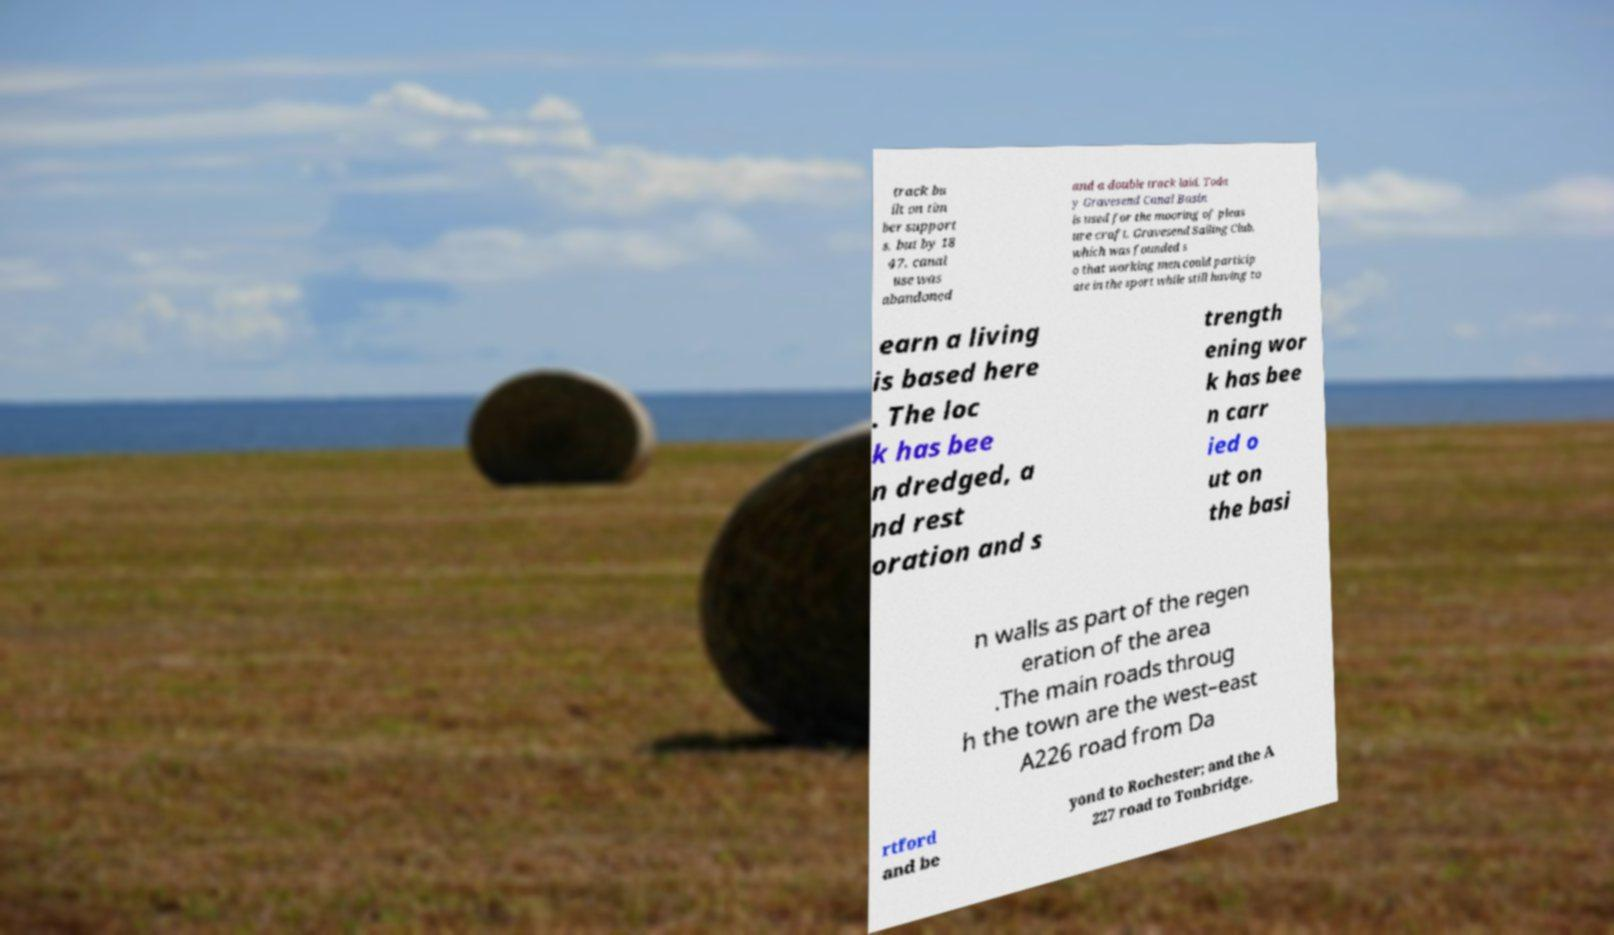For documentation purposes, I need the text within this image transcribed. Could you provide that? track bu ilt on tim ber support s, but by 18 47, canal use was abandoned and a double track laid. Toda y Gravesend Canal Basin is used for the mooring of pleas ure craft. Gravesend Sailing Club, which was founded s o that working men could particip ate in the sport while still having to earn a living is based here . The loc k has bee n dredged, a nd rest oration and s trength ening wor k has bee n carr ied o ut on the basi n walls as part of the regen eration of the area .The main roads throug h the town are the west–east A226 road from Da rtford and be yond to Rochester; and the A 227 road to Tonbridge. 